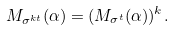Convert formula to latex. <formula><loc_0><loc_0><loc_500><loc_500>M _ { \sigma ^ { k t } } ( \alpha ) = ( M _ { \sigma ^ { t } } ( \alpha ) ) ^ { k } .</formula> 